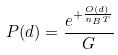Convert formula to latex. <formula><loc_0><loc_0><loc_500><loc_500>P ( d ) = \frac { e ^ { + \frac { O ( d ) } { n _ { B } T } } } { G }</formula> 